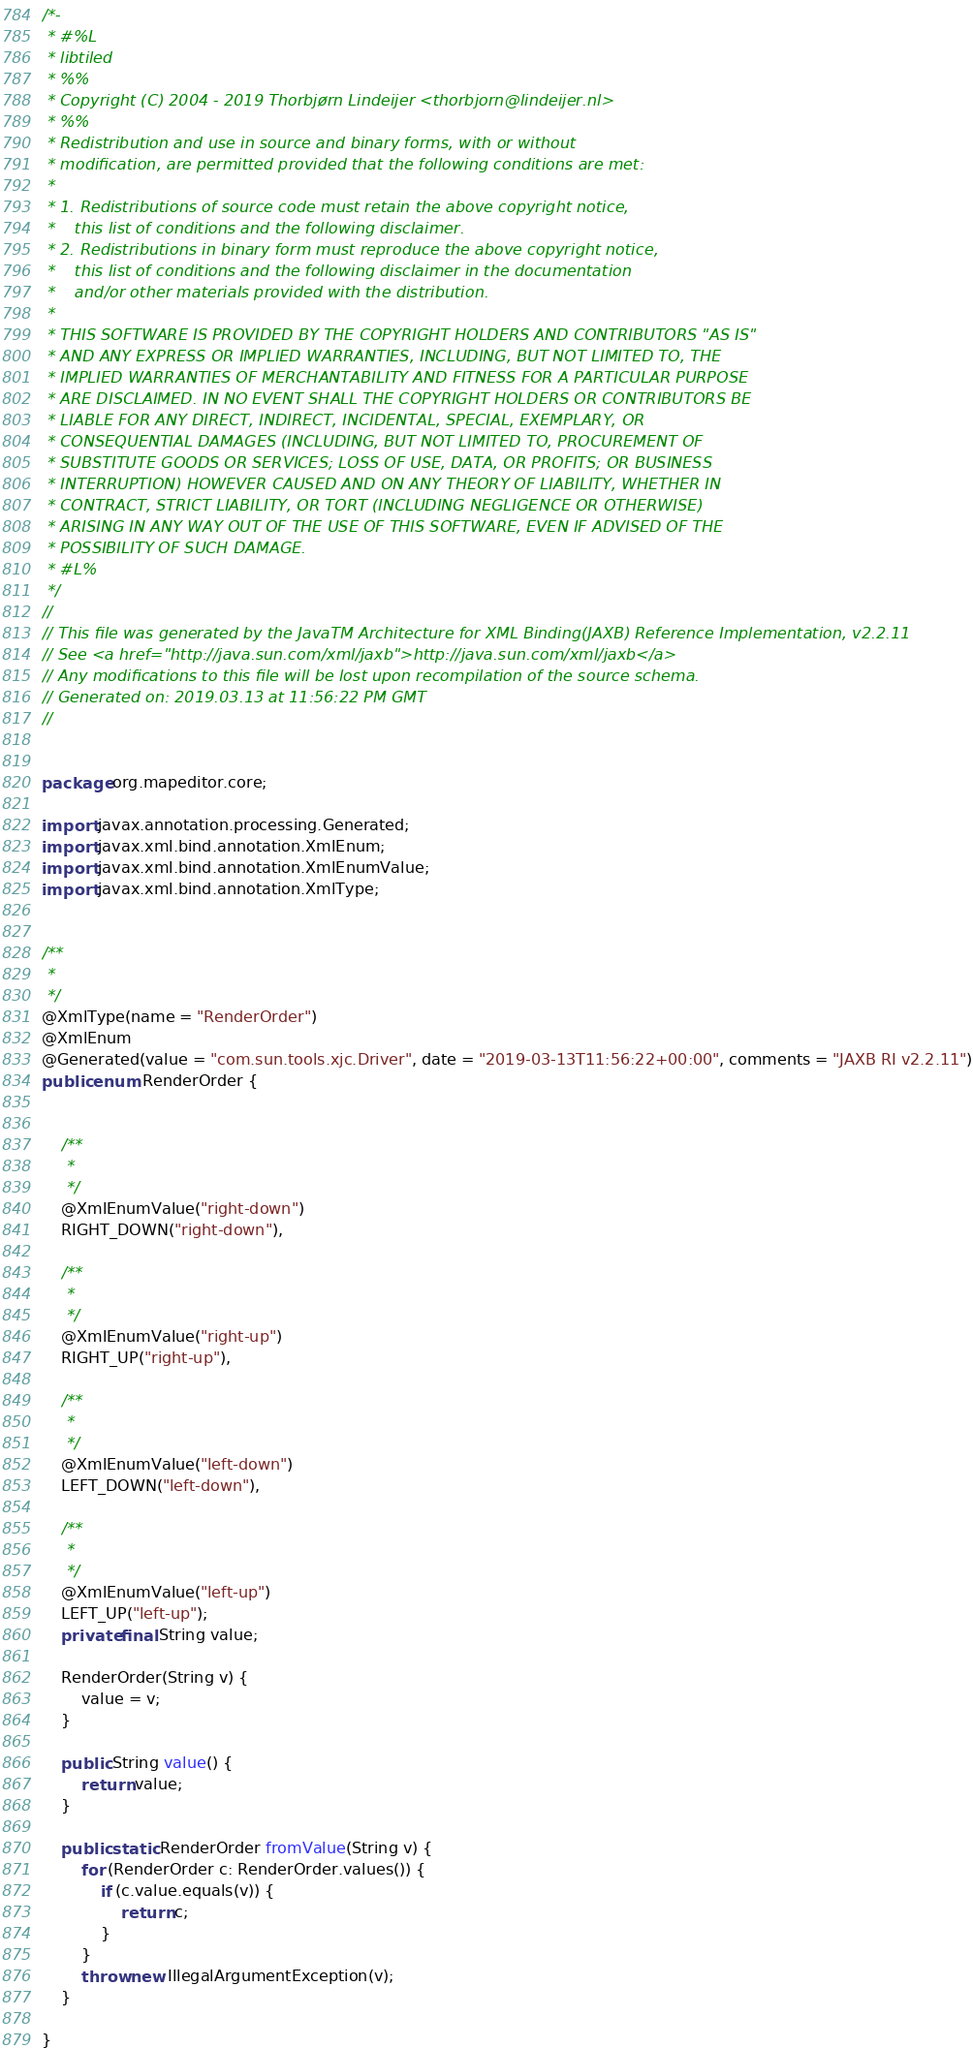<code> <loc_0><loc_0><loc_500><loc_500><_Java_>/*-
 * #%L
 * libtiled
 * %%
 * Copyright (C) 2004 - 2019 Thorbjørn Lindeijer <thorbjorn@lindeijer.nl>
 * %%
 * Redistribution and use in source and binary forms, with or without
 * modification, are permitted provided that the following conditions are met:
 * 
 * 1. Redistributions of source code must retain the above copyright notice,
 *    this list of conditions and the following disclaimer.
 * 2. Redistributions in binary form must reproduce the above copyright notice,
 *    this list of conditions and the following disclaimer in the documentation
 *    and/or other materials provided with the distribution.
 * 
 * THIS SOFTWARE IS PROVIDED BY THE COPYRIGHT HOLDERS AND CONTRIBUTORS "AS IS"
 * AND ANY EXPRESS OR IMPLIED WARRANTIES, INCLUDING, BUT NOT LIMITED TO, THE
 * IMPLIED WARRANTIES OF MERCHANTABILITY AND FITNESS FOR A PARTICULAR PURPOSE
 * ARE DISCLAIMED. IN NO EVENT SHALL THE COPYRIGHT HOLDERS OR CONTRIBUTORS BE
 * LIABLE FOR ANY DIRECT, INDIRECT, INCIDENTAL, SPECIAL, EXEMPLARY, OR
 * CONSEQUENTIAL DAMAGES (INCLUDING, BUT NOT LIMITED TO, PROCUREMENT OF
 * SUBSTITUTE GOODS OR SERVICES; LOSS OF USE, DATA, OR PROFITS; OR BUSINESS
 * INTERRUPTION) HOWEVER CAUSED AND ON ANY THEORY OF LIABILITY, WHETHER IN
 * CONTRACT, STRICT LIABILITY, OR TORT (INCLUDING NEGLIGENCE OR OTHERWISE)
 * ARISING IN ANY WAY OUT OF THE USE OF THIS SOFTWARE, EVEN IF ADVISED OF THE
 * POSSIBILITY OF SUCH DAMAGE.
 * #L%
 */
//
// This file was generated by the JavaTM Architecture for XML Binding(JAXB) Reference Implementation, v2.2.11 
// See <a href="http://java.sun.com/xml/jaxb">http://java.sun.com/xml/jaxb</a> 
// Any modifications to this file will be lost upon recompilation of the source schema. 
// Generated on: 2019.03.13 at 11:56:22 PM GMT 
//


package org.mapeditor.core;

import javax.annotation.processing.Generated;
import javax.xml.bind.annotation.XmlEnum;
import javax.xml.bind.annotation.XmlEnumValue;
import javax.xml.bind.annotation.XmlType;


/**
 * 
 */
@XmlType(name = "RenderOrder")
@XmlEnum
@Generated(value = "com.sun.tools.xjc.Driver", date = "2019-03-13T11:56:22+00:00", comments = "JAXB RI v2.2.11")
public enum RenderOrder {


    /**
     * 
     */
    @XmlEnumValue("right-down")
    RIGHT_DOWN("right-down"),

    /**
     * 
     */
    @XmlEnumValue("right-up")
    RIGHT_UP("right-up"),

    /**
     * 
     */
    @XmlEnumValue("left-down")
    LEFT_DOWN("left-down"),

    /**
     * 
     */
    @XmlEnumValue("left-up")
    LEFT_UP("left-up");
    private final String value;

    RenderOrder(String v) {
        value = v;
    }

    public String value() {
        return value;
    }

    public static RenderOrder fromValue(String v) {
        for (RenderOrder c: RenderOrder.values()) {
            if (c.value.equals(v)) {
                return c;
            }
        }
        throw new IllegalArgumentException(v);
    }

}
</code> 